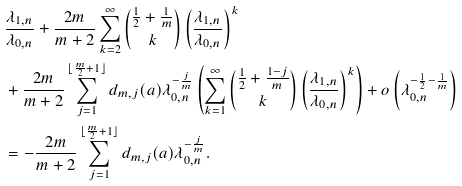<formula> <loc_0><loc_0><loc_500><loc_500>& \frac { \lambda _ { 1 , n } } { \lambda _ { 0 , n } } + \frac { 2 m } { m + 2 } \sum _ { k = 2 } ^ { \infty } { \frac { 1 } { 2 } + \frac { 1 } { m } \choose k } \left ( \frac { \lambda _ { 1 , n } } { \lambda _ { 0 , n } } \right ) ^ { k } \\ & + \frac { 2 m } { m + 2 } \sum _ { j = 1 } ^ { \lfloor \frac { m } { 2 } + 1 \rfloor } d _ { m , j } ( a ) \lambda _ { 0 , n } ^ { - \frac { j } { m } } \left ( \sum _ { k = 1 } ^ { \infty } { \frac { 1 } { 2 } + \frac { 1 - j } { m } \choose k } \left ( \frac { \lambda _ { 1 , n } } { \lambda _ { 0 , n } } \right ) ^ { k } \right ) + o \left ( \lambda _ { 0 , n } ^ { - \frac { 1 } { 2 } - \frac { 1 } { m } } \right ) \\ & = - \frac { 2 m } { m + 2 } \sum _ { j = 1 } ^ { \lfloor \frac { m } { 2 } + 1 \rfloor } d _ { m , j } ( a ) \lambda _ { 0 , n } ^ { - \frac { j } { m } } .</formula> 